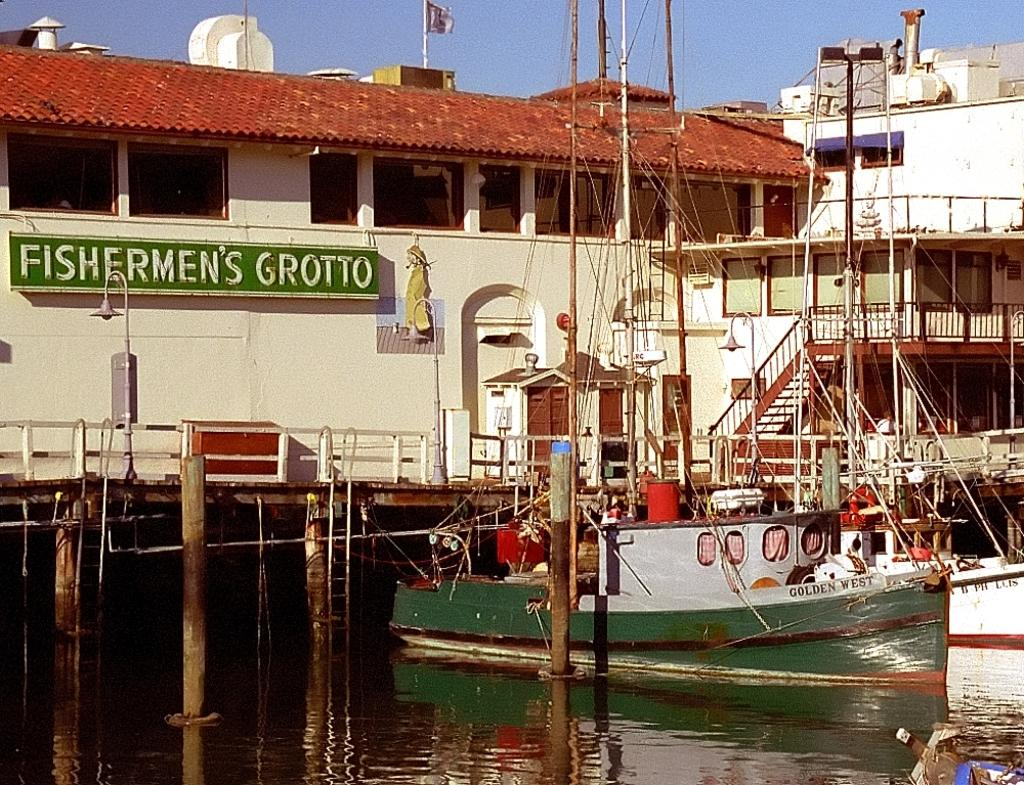<image>
Share a concise interpretation of the image provided. A dockside scene which has Fishermen's Grotto written on a sign. 